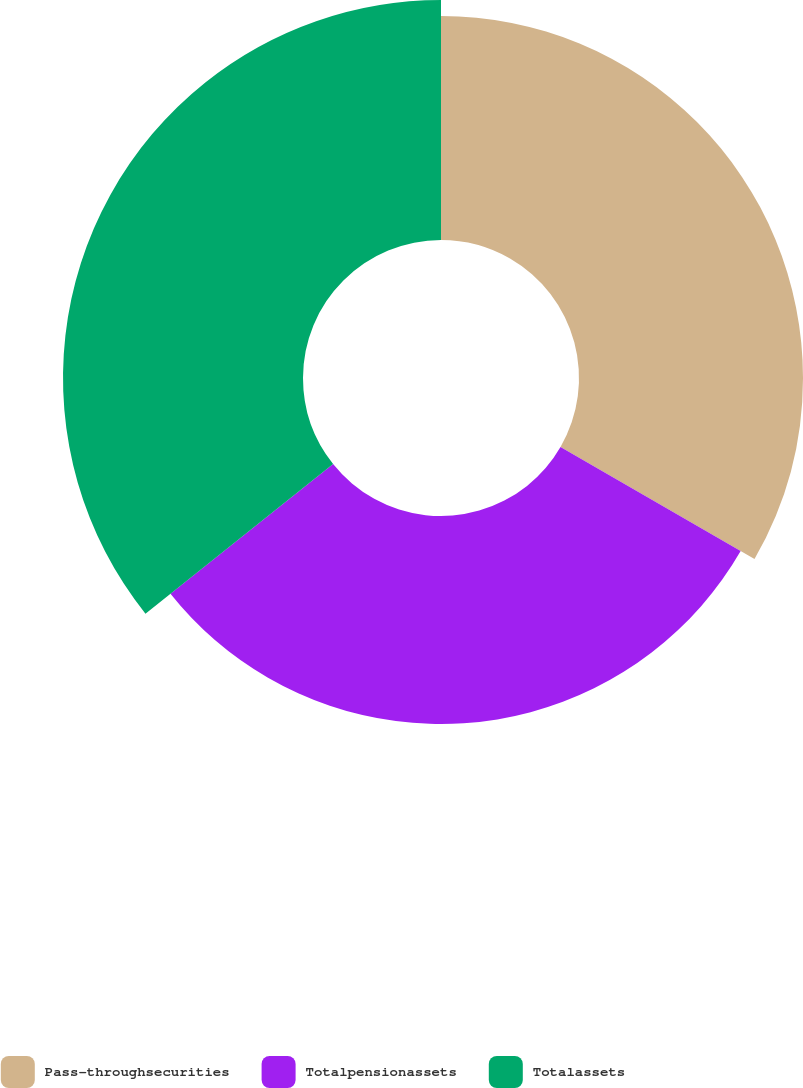Convert chart to OTSL. <chart><loc_0><loc_0><loc_500><loc_500><pie_chart><fcel>Pass-throughsecurities<fcel>Totalpensionassets<fcel>Totalassets<nl><fcel>33.33%<fcel>30.95%<fcel>35.71%<nl></chart> 